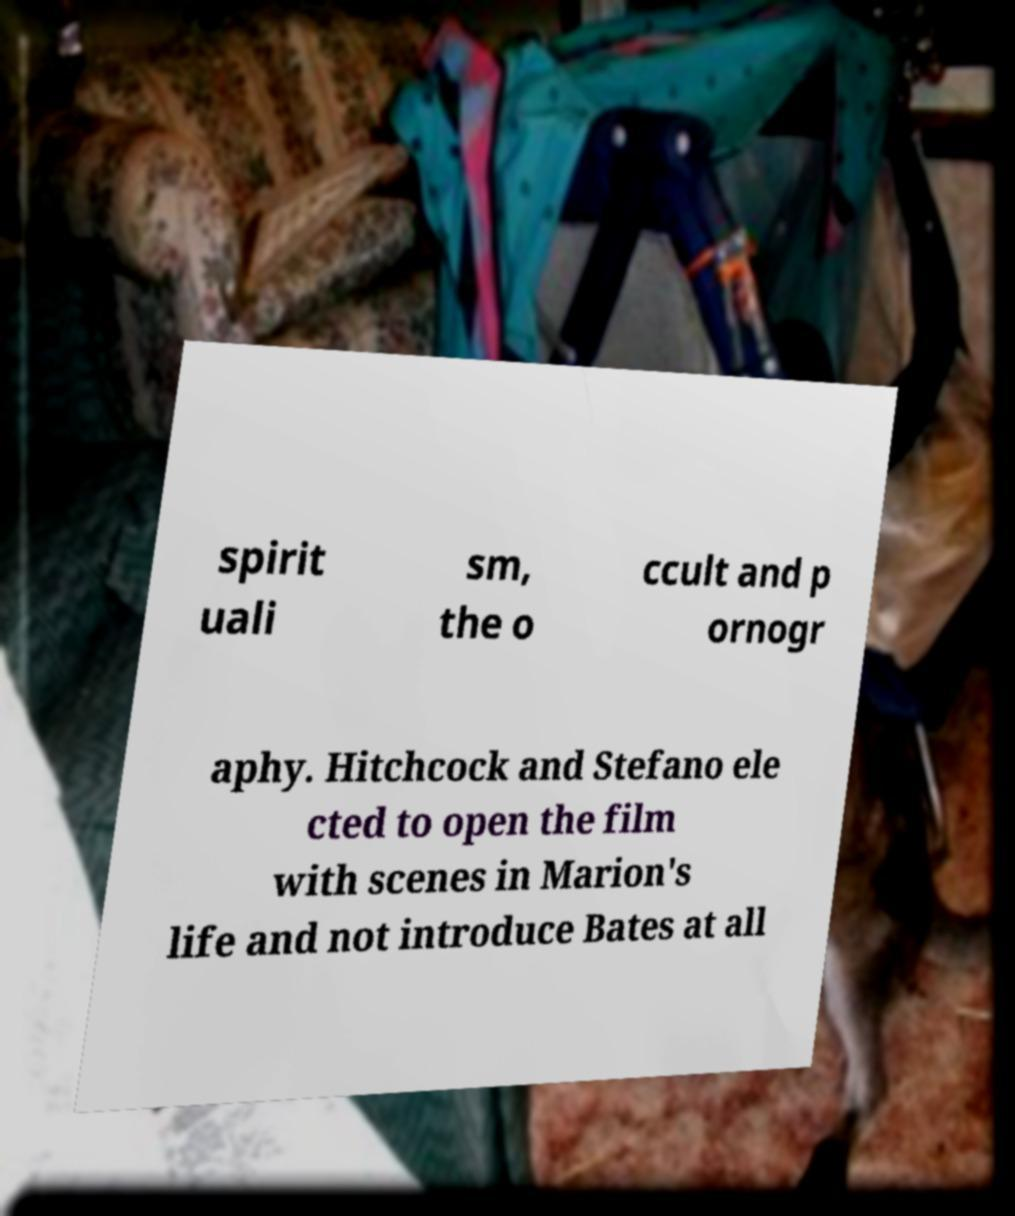There's text embedded in this image that I need extracted. Can you transcribe it verbatim? spirit uali sm, the o ccult and p ornogr aphy. Hitchcock and Stefano ele cted to open the film with scenes in Marion's life and not introduce Bates at all 